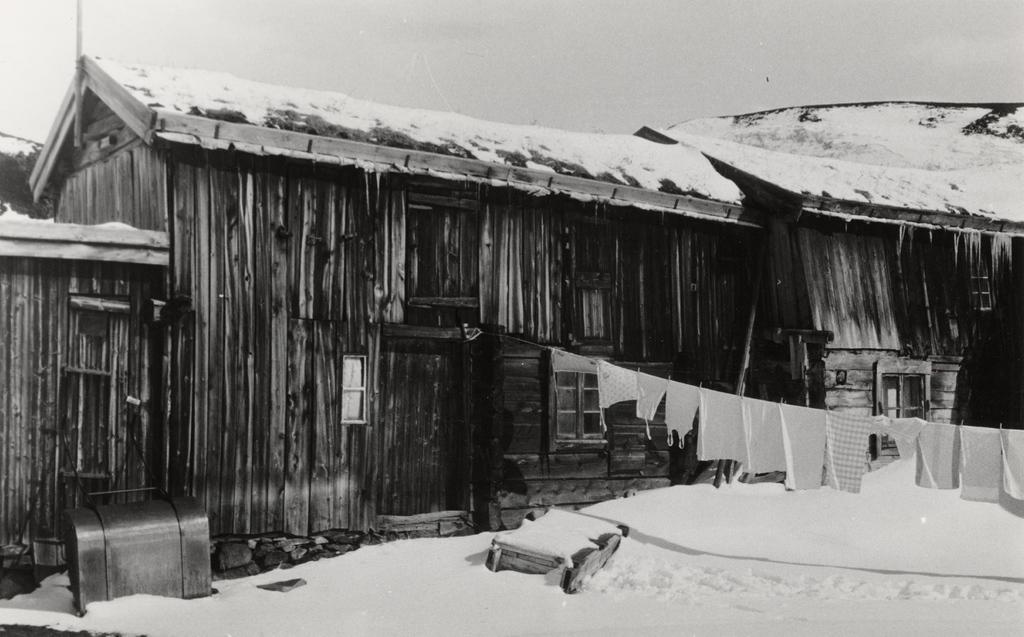Could you give a brief overview of what you see in this image? This picture is in black and white. Here, we see a building which is made up of wood. The roof of the building is covered with ice. At the bottom of the picture, we see the ice. On the right corner of the picture, we see clothes hanged with the rope. On the left side, we see a wooden box. 